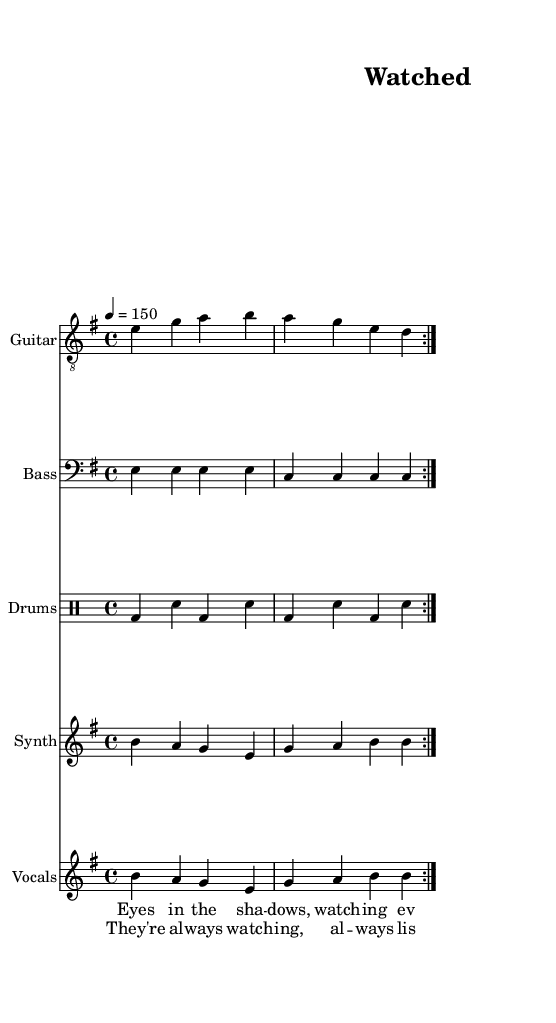What is the key signature of this music? The key signature is indicated at the beginning of the staff. Here, we see one sharp on the staff, which is characteristic of E minor.
Answer: E minor What is the time signature of this piece? The time signature is shown at the beginning of the staff. In this case, it is 4/4, indicating four beats per measure, which is common in metal music.
Answer: 4/4 What is the tempo marking for this piece? The tempo is indicated above the staff, marked as 4 = 150, meaning there are 150 beats per minute.
Answer: 150 How many measures are in the repeat section? By analyzing the score, we can see that the guitar, bass, and drums repeat two measures in the volta sections. Therefore, there are two measures in the repeat section.
Answer: 2 What repeating elements can be found in the vocal section? The vocal section contains repeated lyrics such as "always watching" and "no place to hide," emphasizing the themes of surveillance and paranoia throughout the song.
Answer: always watching, no place to hide What is the primary theme of the lyrics in this piece? The lyrics consistently reflect a feeling of being monitored and a deep sense of paranoia, which indicates the primary theme is surveillance and the emotional effects it has.
Answer: surveillance and paranoia How does the instrumentation reflect the industrial metal genre? The instrumentation includes heavy guitar riffs, synths, and aggressive drum patterns, which are common in industrial metal, creating a mechanical and oppressive sound that enhances the lyrical themes.
Answer: heavy guitar riffs, synths, aggressive drums 